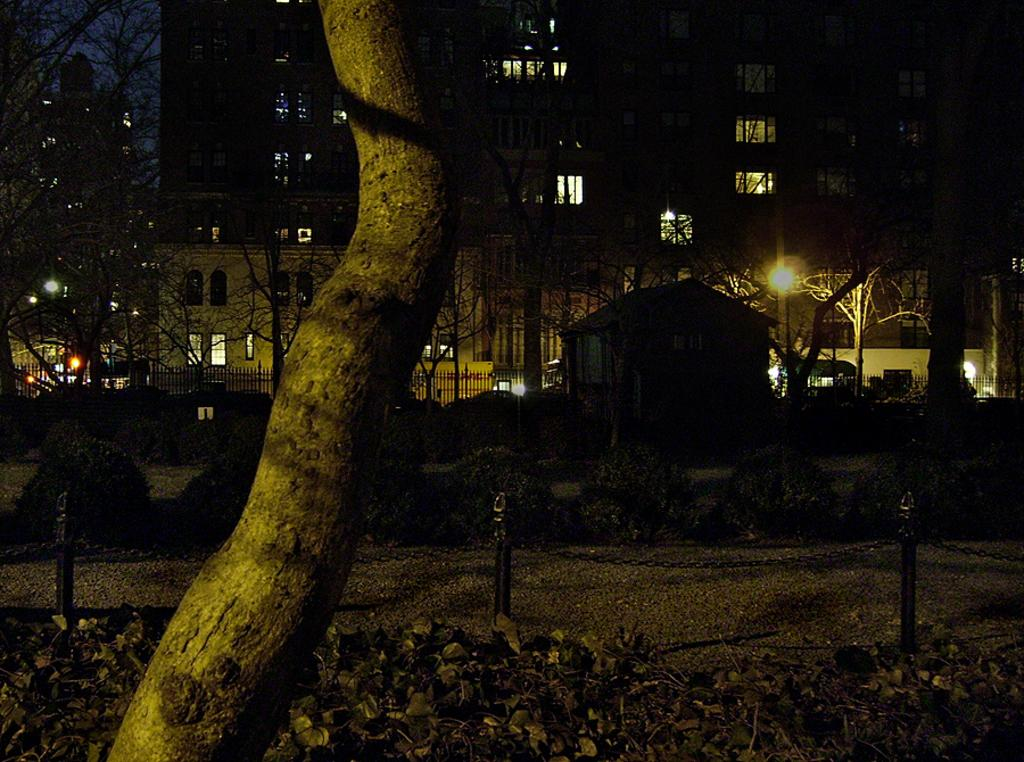What is the lighting condition in the image? The image is taken in the dark. What type of vegetation can be seen in the image? There are shrubs and trees in the image. What type of structure is present in the image? There is a fence, a house, and buildings in the image. What other objects can be seen in the image? There are light poles in the image. What is the color of the sky in the background? The sky in the background is dark. Can you see a rabbit biting a sail in the image? No, there is no rabbit or sail present in the image. 